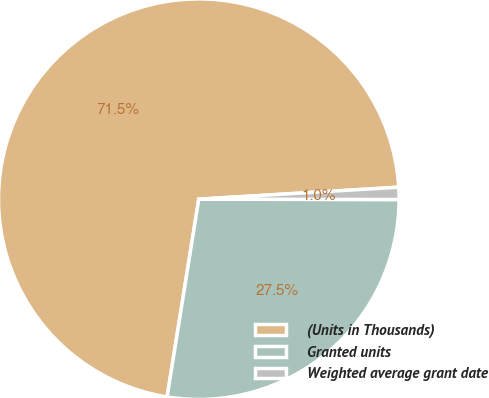Convert chart. <chart><loc_0><loc_0><loc_500><loc_500><pie_chart><fcel>(Units in Thousands)<fcel>Granted units<fcel>Weighted average grant date<nl><fcel>71.52%<fcel>27.5%<fcel>0.98%<nl></chart> 